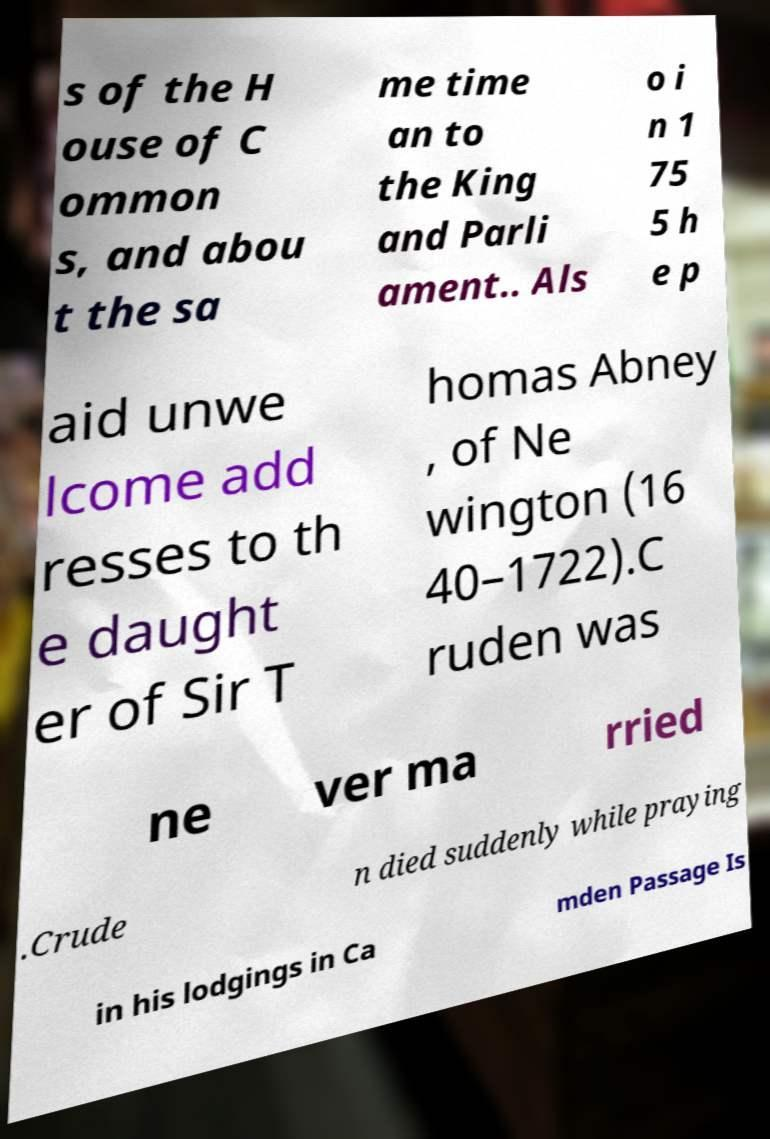Can you read and provide the text displayed in the image?This photo seems to have some interesting text. Can you extract and type it out for me? s of the H ouse of C ommon s, and abou t the sa me time an to the King and Parli ament.. Als o i n 1 75 5 h e p aid unwe lcome add resses to th e daught er of Sir T homas Abney , of Ne wington (16 40–1722).C ruden was ne ver ma rried .Crude n died suddenly while praying in his lodgings in Ca mden Passage Is 